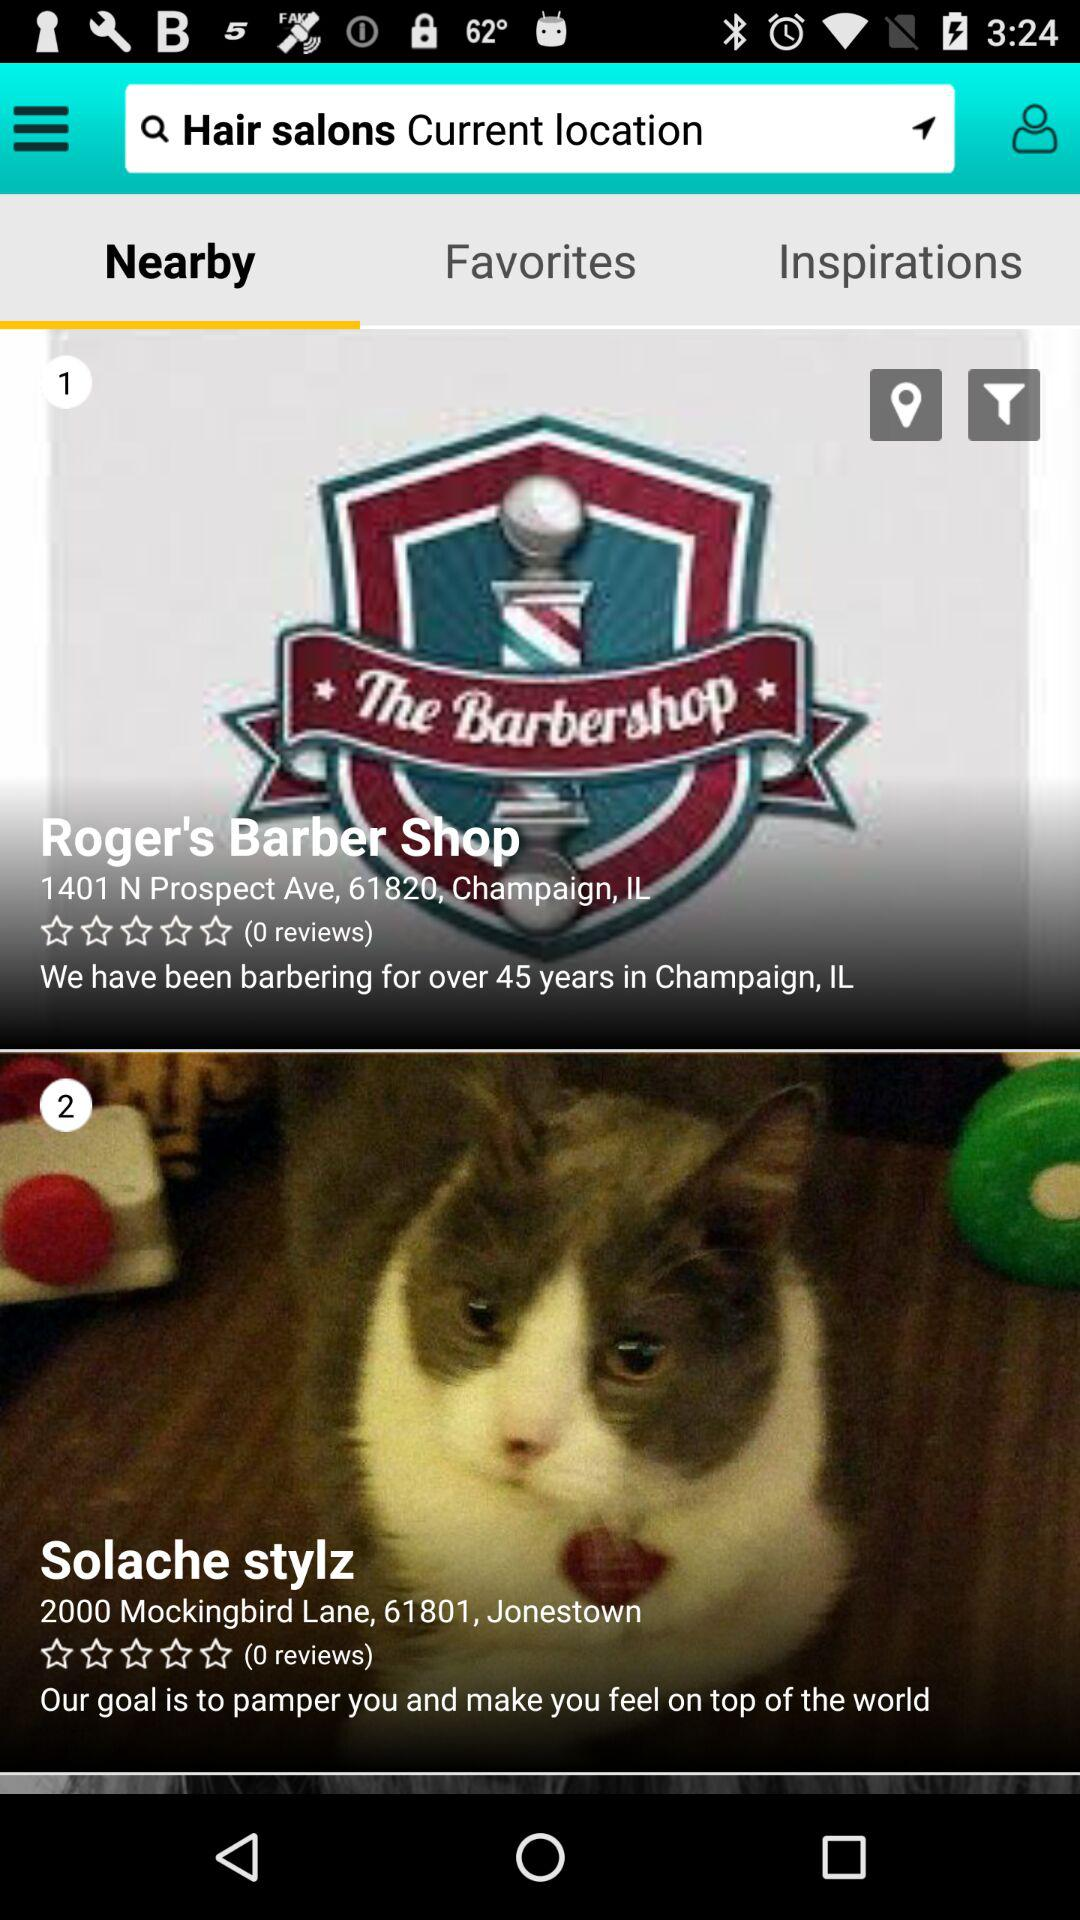How many reviews are there for Roger's Barber Shop? There are 0 reviews. 